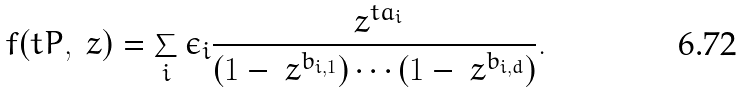Convert formula to latex. <formula><loc_0><loc_0><loc_500><loc_500>f ( t P , \ z ) = \sum _ { i } \epsilon _ { i } \frac { \ z ^ { t a _ { i } } } { ( 1 - \ z ^ { b _ { i , 1 } } ) \cdots ( 1 - \ z ^ { b _ { i , d } } ) } .</formula> 